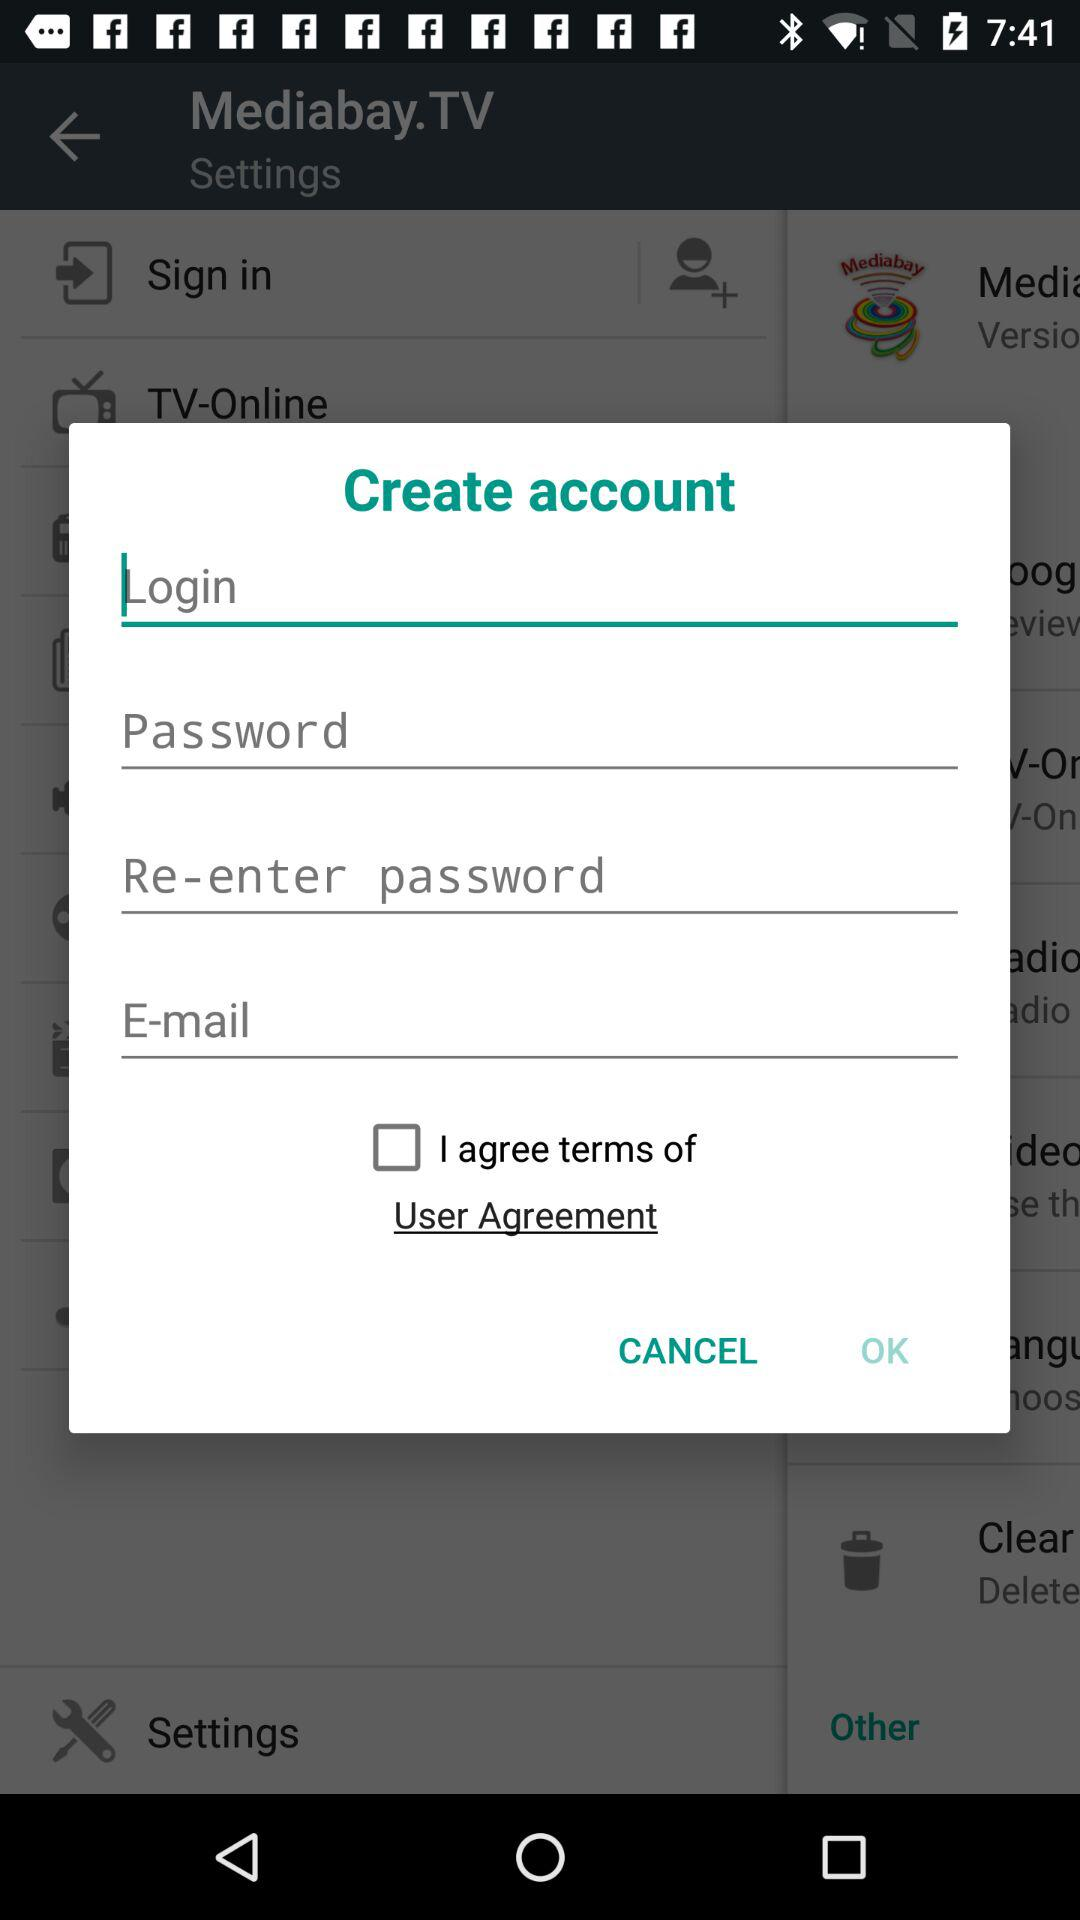What is the status of the option that includes agreement to the "User Agreement"? The status is "off". 